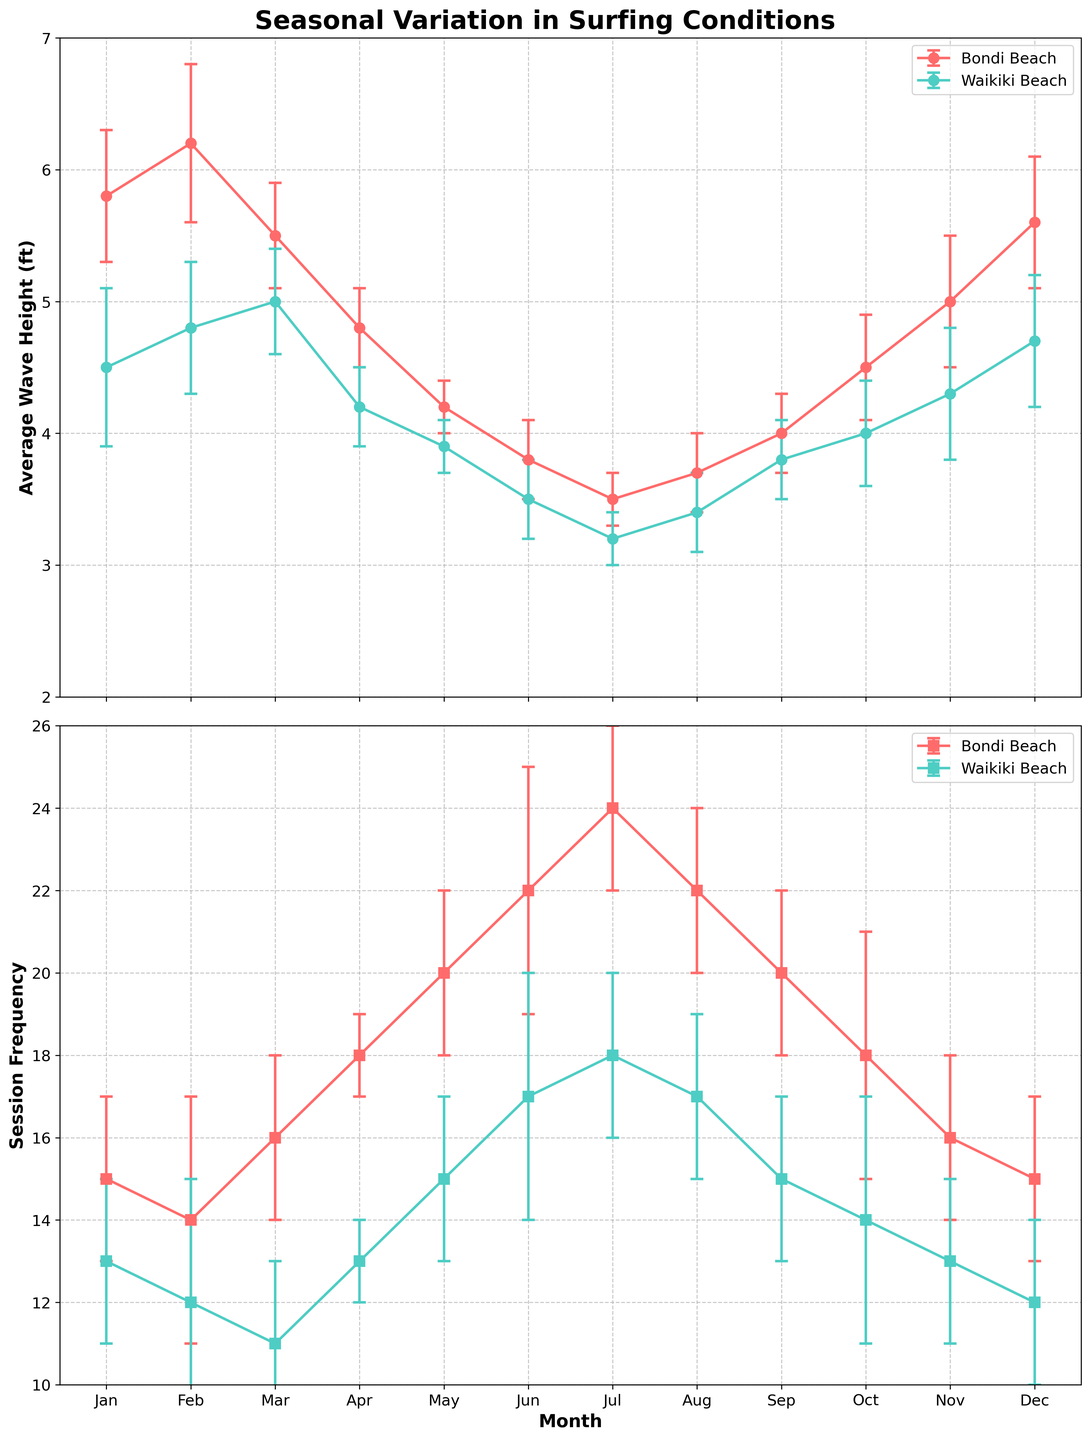What is the title of the figure? The title is located at the top center of the plot and reads "Seasonal Variation in Surfing Conditions."
Answer: Seasonal Variation in Surfing Conditions What are the labels for the y-axes of the two subplots? The label for the y-axis of the first subplot is "Average Wave Height (ft)" and for the second subplot is "Session Frequency." These are shown on the left side of each respective subplot.
Answer: Average Wave Height (ft), Session Frequency In which month does Bondi Beach have the highest average wave height? Bondi Beach's wave height data is plotted with circles on the first subplot. By following the highest point on this line, you can see it reaches its peak in February.
Answer: February Which beach has a higher session frequency in July, and by how much? July is the seventh point on the x-axis. In the second subplot, the values for Bondi Beach and Waikiki Beach are 24 and 18, respectively. The difference is 24 - 18.
Answer: Bondi Beach, 6 How does the average wave height trend at Bondi Beach change from January to July? Observe the red line with circles on the first subplot for Bondi Beach from the first to the seventh month. It starts high in January and decreases steadily towards July.
Answer: Decreases Which location has less variation in session frequency in August, Bondi Beach or Waikiki Beach? Check the error bars on the session frequency plot for August. Bondi Beach shows a smaller error variation compared to Waikiki Beach.
Answer: Bondi Beach In which month is the variation in average session duration the highest for Waikiki Beach? Variation is indicated by the size of the error bars in the average session duration data points. Compare the markers for each month and identify the largest error bar for Waikiki Beach.
Answer: January How does the session frequency in December compare between Bondi Beach and Waikiki Beach, and what is the difference? December is the twelfth point on the x-axis. In the second subplot, Bondi Beach has a session frequency of 15 and Waikiki Beach's is 12. Subtract to find the difference 15 - 12.
Answer: Bondi Beach is higher by 3 Is there a month where Bondi Beach and Waikiki Beach have the same average wave height? If yes, which month? Look for overlapping points on the first subplot. In September, both Bondi Beach and Waikiki Beach have approximately the same average wave height (4.0 ft).
Answer: Yes, September Which beach generally has higher average session duration throughout the year, and how can you tell? Waikiki Beach indeed has consistently higher average session duration than Bondi Beach, as depicted in the data bar of one subplot for Waikiki Beach line being above the Bondi Beach line for session duration.
Answer: Waikiki Beach 